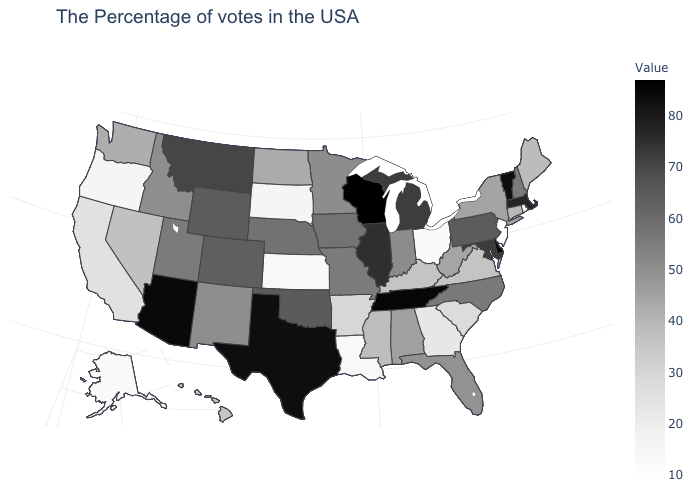Among the states that border New Mexico , which have the lowest value?
Quick response, please. Utah. Does Nevada have a lower value than New Mexico?
Answer briefly. Yes. Does New Jersey have the lowest value in the USA?
Quick response, please. Yes. Which states have the highest value in the USA?
Short answer required. Wisconsin. Which states have the lowest value in the USA?
Write a very short answer. New Jersey. Which states have the highest value in the USA?
Concise answer only. Wisconsin. Which states have the lowest value in the USA?
Quick response, please. New Jersey. Does Arkansas have a lower value than New Mexico?
Write a very short answer. Yes. 